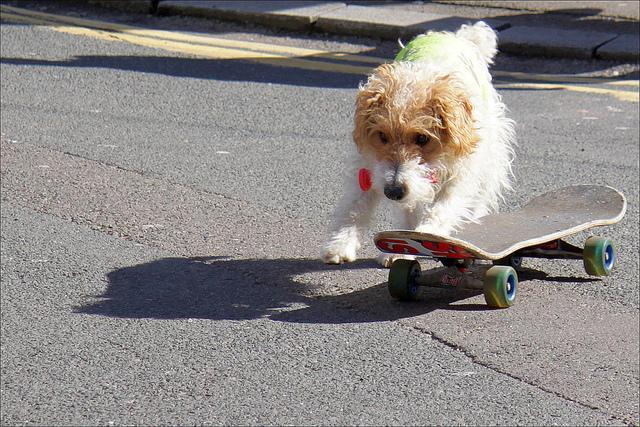How many skateboards can be seen?
Give a very brief answer. 1. How many cars are the same color as the fire hydrant?
Give a very brief answer. 0. 